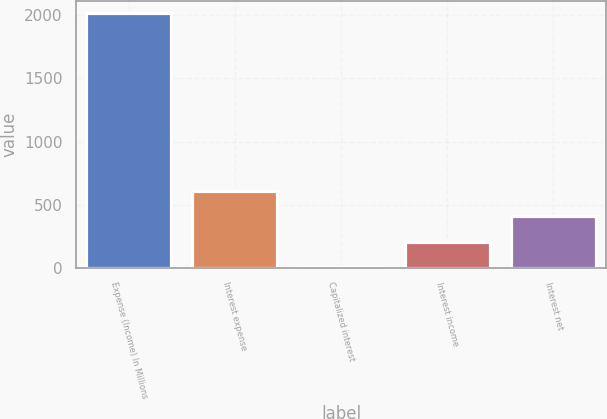<chart> <loc_0><loc_0><loc_500><loc_500><bar_chart><fcel>Expense (Income) In Millions<fcel>Interest expense<fcel>Capitalized interest<fcel>Interest income<fcel>Interest net<nl><fcel>2015<fcel>609.33<fcel>6.9<fcel>207.71<fcel>408.52<nl></chart> 